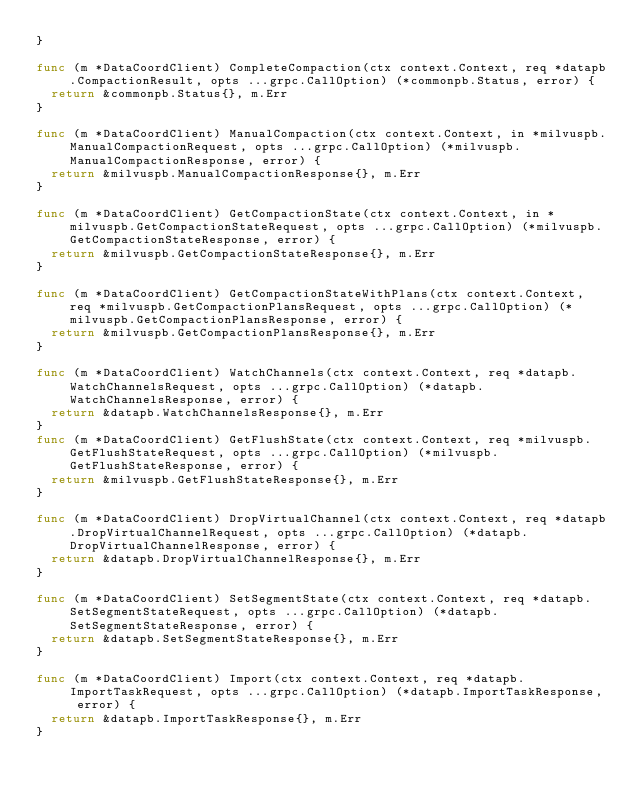Convert code to text. <code><loc_0><loc_0><loc_500><loc_500><_Go_>}

func (m *DataCoordClient) CompleteCompaction(ctx context.Context, req *datapb.CompactionResult, opts ...grpc.CallOption) (*commonpb.Status, error) {
	return &commonpb.Status{}, m.Err
}

func (m *DataCoordClient) ManualCompaction(ctx context.Context, in *milvuspb.ManualCompactionRequest, opts ...grpc.CallOption) (*milvuspb.ManualCompactionResponse, error) {
	return &milvuspb.ManualCompactionResponse{}, m.Err
}

func (m *DataCoordClient) GetCompactionState(ctx context.Context, in *milvuspb.GetCompactionStateRequest, opts ...grpc.CallOption) (*milvuspb.GetCompactionStateResponse, error) {
	return &milvuspb.GetCompactionStateResponse{}, m.Err
}

func (m *DataCoordClient) GetCompactionStateWithPlans(ctx context.Context, req *milvuspb.GetCompactionPlansRequest, opts ...grpc.CallOption) (*milvuspb.GetCompactionPlansResponse, error) {
	return &milvuspb.GetCompactionPlansResponse{}, m.Err
}

func (m *DataCoordClient) WatchChannels(ctx context.Context, req *datapb.WatchChannelsRequest, opts ...grpc.CallOption) (*datapb.WatchChannelsResponse, error) {
	return &datapb.WatchChannelsResponse{}, m.Err
}
func (m *DataCoordClient) GetFlushState(ctx context.Context, req *milvuspb.GetFlushStateRequest, opts ...grpc.CallOption) (*milvuspb.GetFlushStateResponse, error) {
	return &milvuspb.GetFlushStateResponse{}, m.Err
}

func (m *DataCoordClient) DropVirtualChannel(ctx context.Context, req *datapb.DropVirtualChannelRequest, opts ...grpc.CallOption) (*datapb.DropVirtualChannelResponse, error) {
	return &datapb.DropVirtualChannelResponse{}, m.Err
}

func (m *DataCoordClient) SetSegmentState(ctx context.Context, req *datapb.SetSegmentStateRequest, opts ...grpc.CallOption) (*datapb.SetSegmentStateResponse, error) {
	return &datapb.SetSegmentStateResponse{}, m.Err
}

func (m *DataCoordClient) Import(ctx context.Context, req *datapb.ImportTaskRequest, opts ...grpc.CallOption) (*datapb.ImportTaskResponse, error) {
	return &datapb.ImportTaskResponse{}, m.Err
}
</code> 